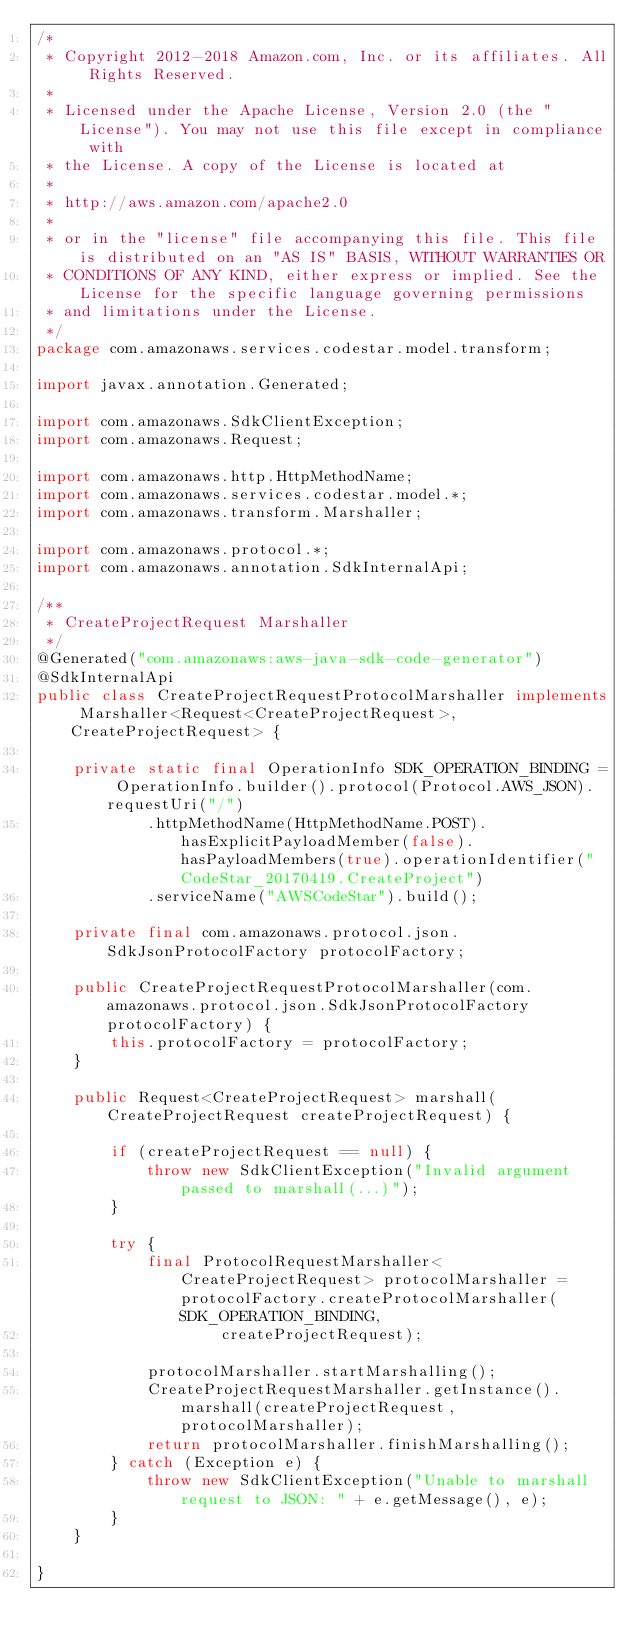Convert code to text. <code><loc_0><loc_0><loc_500><loc_500><_Java_>/*
 * Copyright 2012-2018 Amazon.com, Inc. or its affiliates. All Rights Reserved.
 * 
 * Licensed under the Apache License, Version 2.0 (the "License"). You may not use this file except in compliance with
 * the License. A copy of the License is located at
 * 
 * http://aws.amazon.com/apache2.0
 * 
 * or in the "license" file accompanying this file. This file is distributed on an "AS IS" BASIS, WITHOUT WARRANTIES OR
 * CONDITIONS OF ANY KIND, either express or implied. See the License for the specific language governing permissions
 * and limitations under the License.
 */
package com.amazonaws.services.codestar.model.transform;

import javax.annotation.Generated;

import com.amazonaws.SdkClientException;
import com.amazonaws.Request;

import com.amazonaws.http.HttpMethodName;
import com.amazonaws.services.codestar.model.*;
import com.amazonaws.transform.Marshaller;

import com.amazonaws.protocol.*;
import com.amazonaws.annotation.SdkInternalApi;

/**
 * CreateProjectRequest Marshaller
 */
@Generated("com.amazonaws:aws-java-sdk-code-generator")
@SdkInternalApi
public class CreateProjectRequestProtocolMarshaller implements Marshaller<Request<CreateProjectRequest>, CreateProjectRequest> {

    private static final OperationInfo SDK_OPERATION_BINDING = OperationInfo.builder().protocol(Protocol.AWS_JSON).requestUri("/")
            .httpMethodName(HttpMethodName.POST).hasExplicitPayloadMember(false).hasPayloadMembers(true).operationIdentifier("CodeStar_20170419.CreateProject")
            .serviceName("AWSCodeStar").build();

    private final com.amazonaws.protocol.json.SdkJsonProtocolFactory protocolFactory;

    public CreateProjectRequestProtocolMarshaller(com.amazonaws.protocol.json.SdkJsonProtocolFactory protocolFactory) {
        this.protocolFactory = protocolFactory;
    }

    public Request<CreateProjectRequest> marshall(CreateProjectRequest createProjectRequest) {

        if (createProjectRequest == null) {
            throw new SdkClientException("Invalid argument passed to marshall(...)");
        }

        try {
            final ProtocolRequestMarshaller<CreateProjectRequest> protocolMarshaller = protocolFactory.createProtocolMarshaller(SDK_OPERATION_BINDING,
                    createProjectRequest);

            protocolMarshaller.startMarshalling();
            CreateProjectRequestMarshaller.getInstance().marshall(createProjectRequest, protocolMarshaller);
            return protocolMarshaller.finishMarshalling();
        } catch (Exception e) {
            throw new SdkClientException("Unable to marshall request to JSON: " + e.getMessage(), e);
        }
    }

}
</code> 